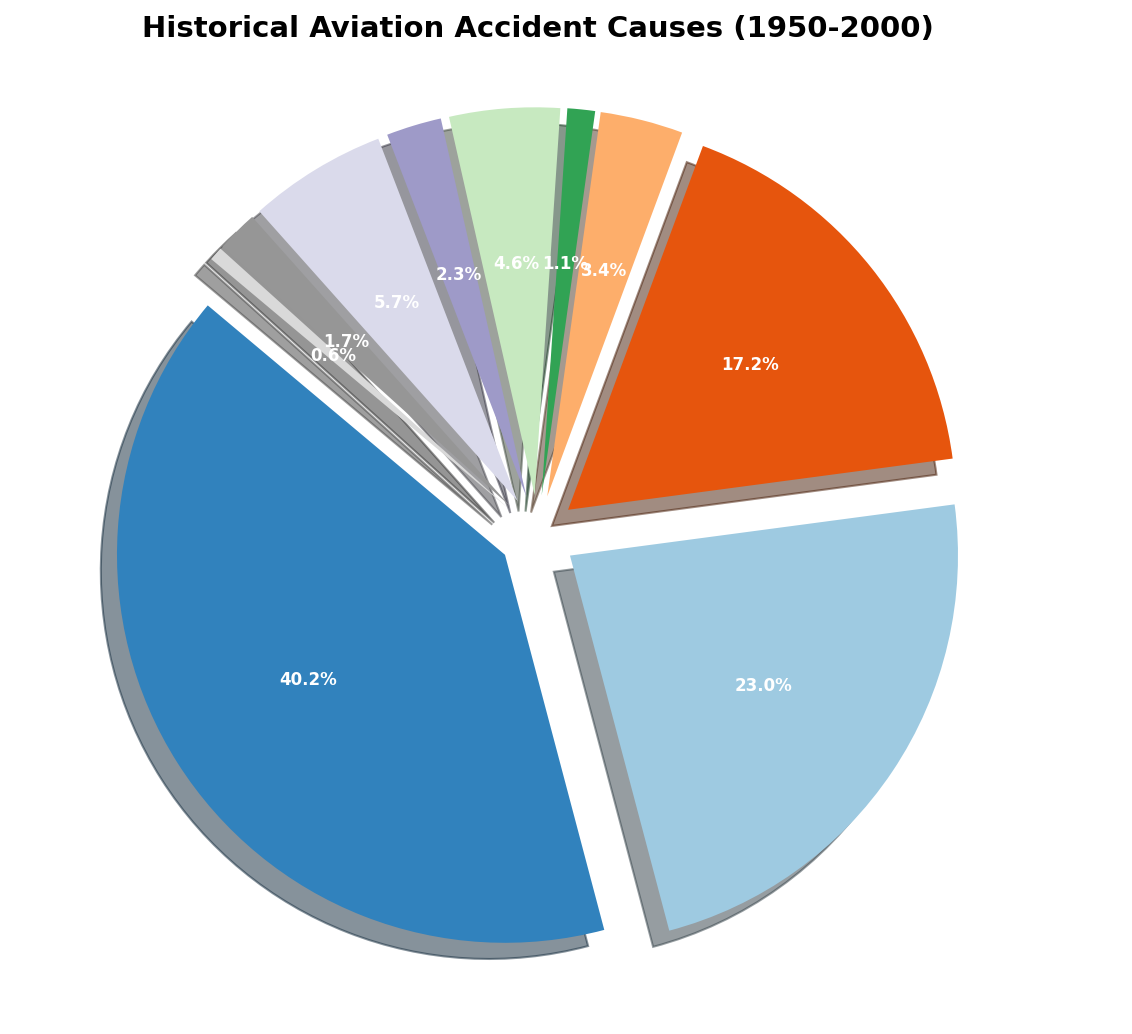Which cause of historical aviation accidents had the highest percentage of occurrences? To answer this question, locate the largest wedge in the pie chart. The label with its corresponding percentage indicates the cause with the highest occurrences.
Answer: Pilot Error What percentage of historical aviation accidents were attributed to mechanical failure? Look at the section of the pie chart labeled 'Mechanical Failure' and read the percentage given there.
Answer: 22.2% How much greater is the percentage of pilot error accidents compared to weather-related accidents? First, find the percentage of accidents caused by pilot error and weather. Subtract the percentage of weather accidents from the percentage of pilot error accidents.
Answer: 51.9% - 22.2% = 29.7% What is the combined percentage of accidents caused by mechanical failure and weather? Add the percentage of accidents caused by mechanical failure to the percentage caused by weather.
Answer: 22.2% + 16.7% = 38.9% Which two categories have the smallest percentage of occurrences, and what are their combined percentages? Identify the smallest wedges in the pie chart, corresponding to the labels 'Bird Strikes' and 'Unknown.' Add their percentages together.
Answer: Bird Strikes (1.1%) and Unknown (0.6%), combined = 1.1% + 0.6% = 1.7% How does the percentage of sabotage-related accidents compare to mid-air collisions? Identify the labels 'Sabotage' and 'Mid-Air Collision' on the pie chart. Compare their given percentages.
Answer: Sabotage is higher (3.3%) compared to Mid-Air Collision (2.2%) How many categories have a percentage of 5% or higher, and what are their names? Count the wedges in the pie chart with labels indicating percentages of 5% or higher, and then list their names.
Answer: Three categories: Pilot Error, Mechanical Failure, Weather What percentage of aviation accidents are attributed to human error, combining pilot errors and other human errors? Add the percentages for 'Pilot Error' and 'Other Human Error.'
Answer: 51.9% + 5.6% = 57.5% What is the percentage difference between controlled flight into terrain (CFIT) and runway incursions? Find the percentage for 'Controlled Flight Into Terrain (CFIT)' and 'Runway Incursions.' Subtract the latter from the former.
Answer: 5.6% - 1.7% = 3.9% What is the visual indication of how much larger the pilot error wedge is compared to the mechanical failure wedge in the pie chart? The 'Pilot Error' wedge is visually the largest and is exploded outward more prominently compared to the 'Mechanical Failure' wedge.
Answer: Pilot Error wedge is significantly larger 